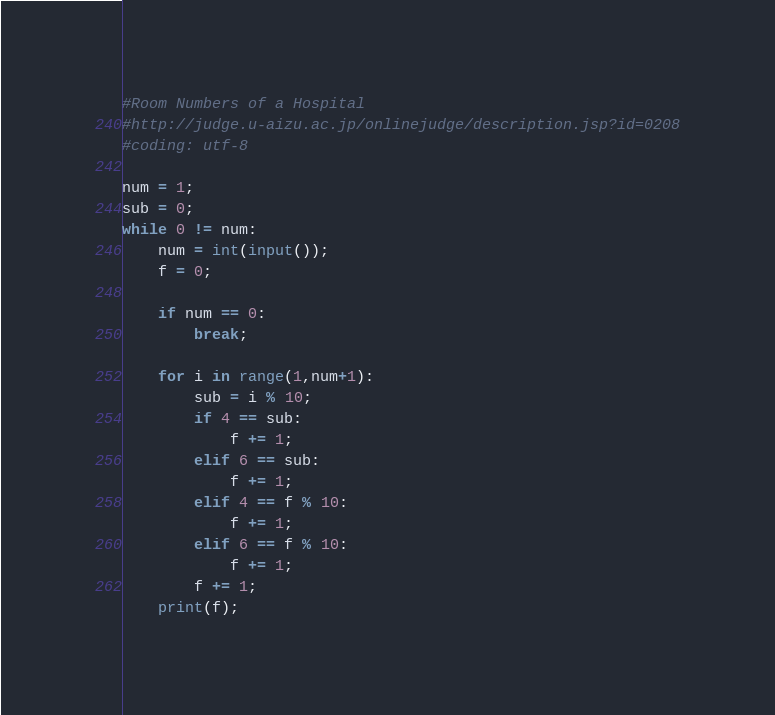<code> <loc_0><loc_0><loc_500><loc_500><_Python_>#Room Numbers of a Hospital
#http://judge.u-aizu.ac.jp/onlinejudge/description.jsp?id=0208
#coding: utf-8

num = 1;
sub = 0;
while 0 != num:
    num = int(input());
    f = 0;

    if num == 0:
        break;

    for i in range(1,num+1):
        sub = i % 10;
        if 4 == sub:
            f += 1;
        elif 6 == sub:
            f += 1;
        elif 4 == f % 10:
            f += 1;
        elif 6 == f % 10:
            f += 1;
        f += 1;
    print(f);</code> 